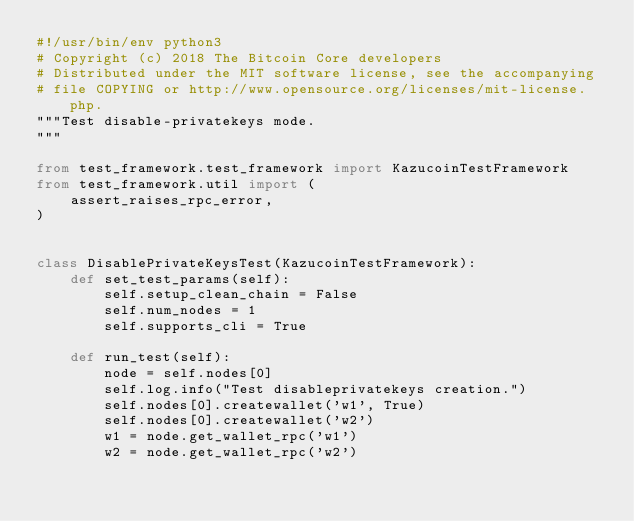Convert code to text. <code><loc_0><loc_0><loc_500><loc_500><_Python_>#!/usr/bin/env python3
# Copyright (c) 2018 The Bitcoin Core developers
# Distributed under the MIT software license, see the accompanying
# file COPYING or http://www.opensource.org/licenses/mit-license.php.
"""Test disable-privatekeys mode.
"""

from test_framework.test_framework import KazucoinTestFramework
from test_framework.util import (
    assert_raises_rpc_error,
)


class DisablePrivateKeysTest(KazucoinTestFramework):
    def set_test_params(self):
        self.setup_clean_chain = False
        self.num_nodes = 1
        self.supports_cli = True

    def run_test(self):
        node = self.nodes[0]
        self.log.info("Test disableprivatekeys creation.")
        self.nodes[0].createwallet('w1', True)
        self.nodes[0].createwallet('w2')
        w1 = node.get_wallet_rpc('w1')
        w2 = node.get_wallet_rpc('w2')</code> 